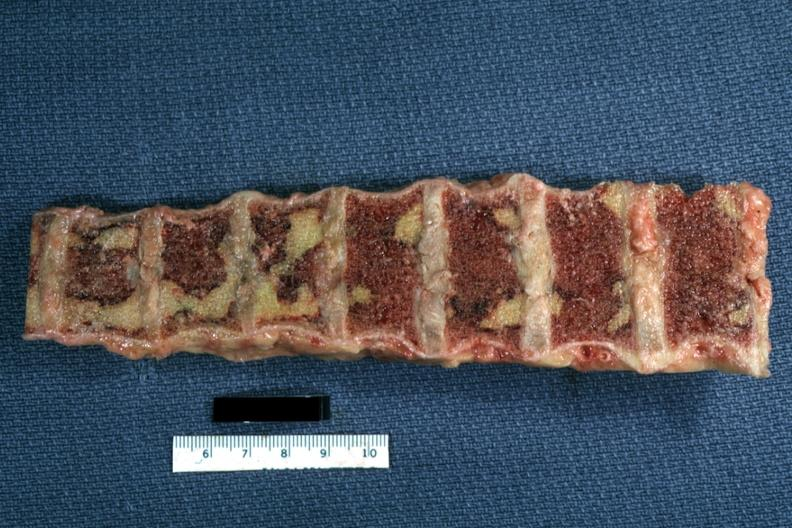what is present?
Answer the question using a single word or phrase. Joints 